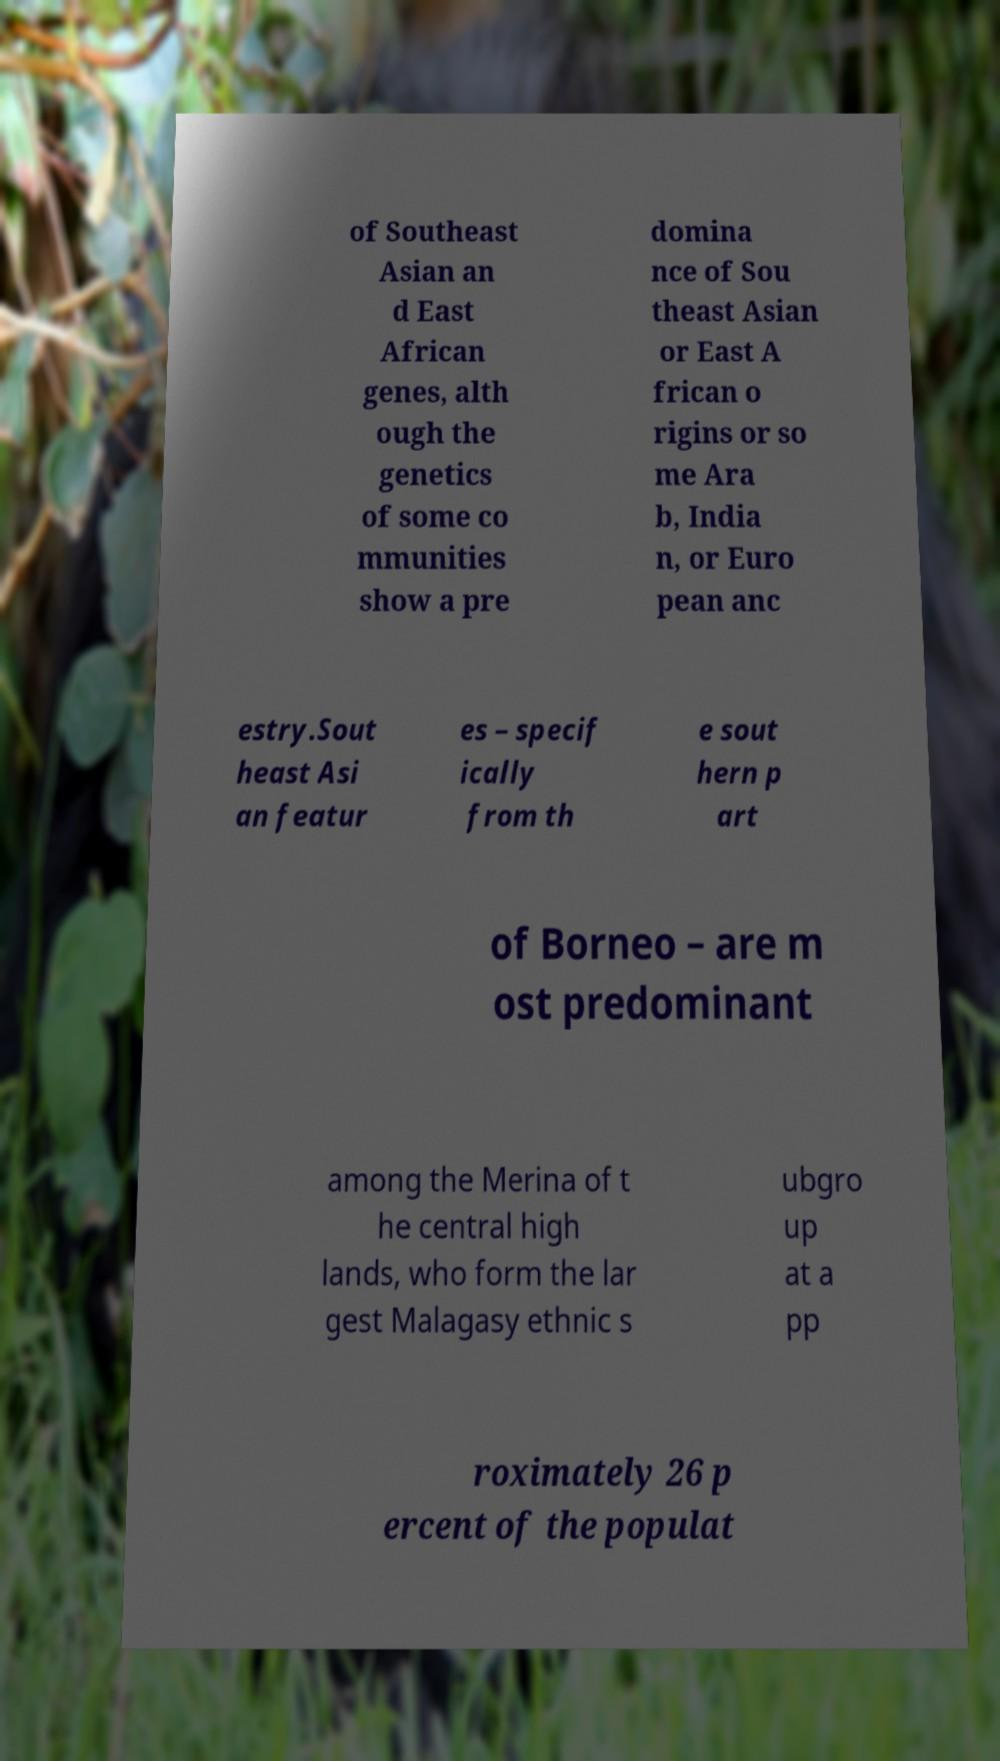Can you read and provide the text displayed in the image?This photo seems to have some interesting text. Can you extract and type it out for me? of Southeast Asian an d East African genes, alth ough the genetics of some co mmunities show a pre domina nce of Sou theast Asian or East A frican o rigins or so me Ara b, India n, or Euro pean anc estry.Sout heast Asi an featur es – specif ically from th e sout hern p art of Borneo – are m ost predominant among the Merina of t he central high lands, who form the lar gest Malagasy ethnic s ubgro up at a pp roximately 26 p ercent of the populat 